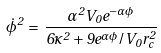<formula> <loc_0><loc_0><loc_500><loc_500>\dot { \phi } ^ { 2 } \, = \, \frac { \alpha ^ { 2 } V _ { 0 } e ^ { - \alpha \phi } } { 6 \kappa ^ { 2 } + 9 e ^ { \alpha \phi } / V _ { 0 } r _ { c } ^ { 2 } }</formula> 